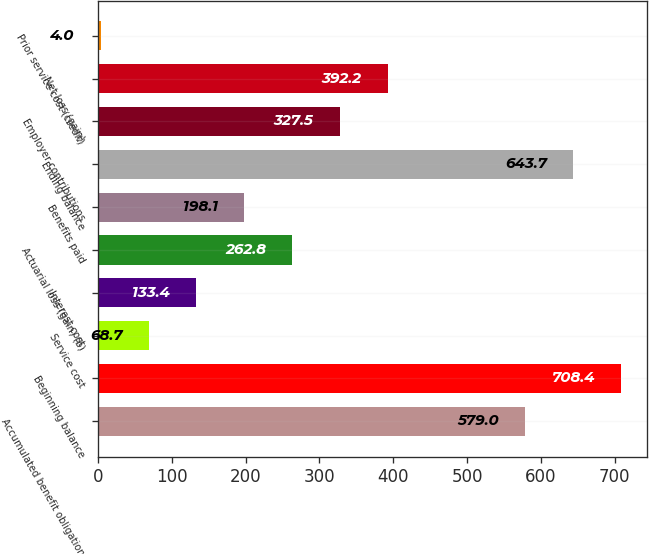Convert chart. <chart><loc_0><loc_0><loc_500><loc_500><bar_chart><fcel>Accumulated benefit obligation<fcel>Beginning balance<fcel>Service cost<fcel>Interest cost<fcel>Actuarial loss (gain) (b)<fcel>Benefits paid<fcel>Ending balance<fcel>Employer contributions<fcel>Net loss (gain)<fcel>Prior service cost (credit)<nl><fcel>579<fcel>708.4<fcel>68.7<fcel>133.4<fcel>262.8<fcel>198.1<fcel>643.7<fcel>327.5<fcel>392.2<fcel>4<nl></chart> 